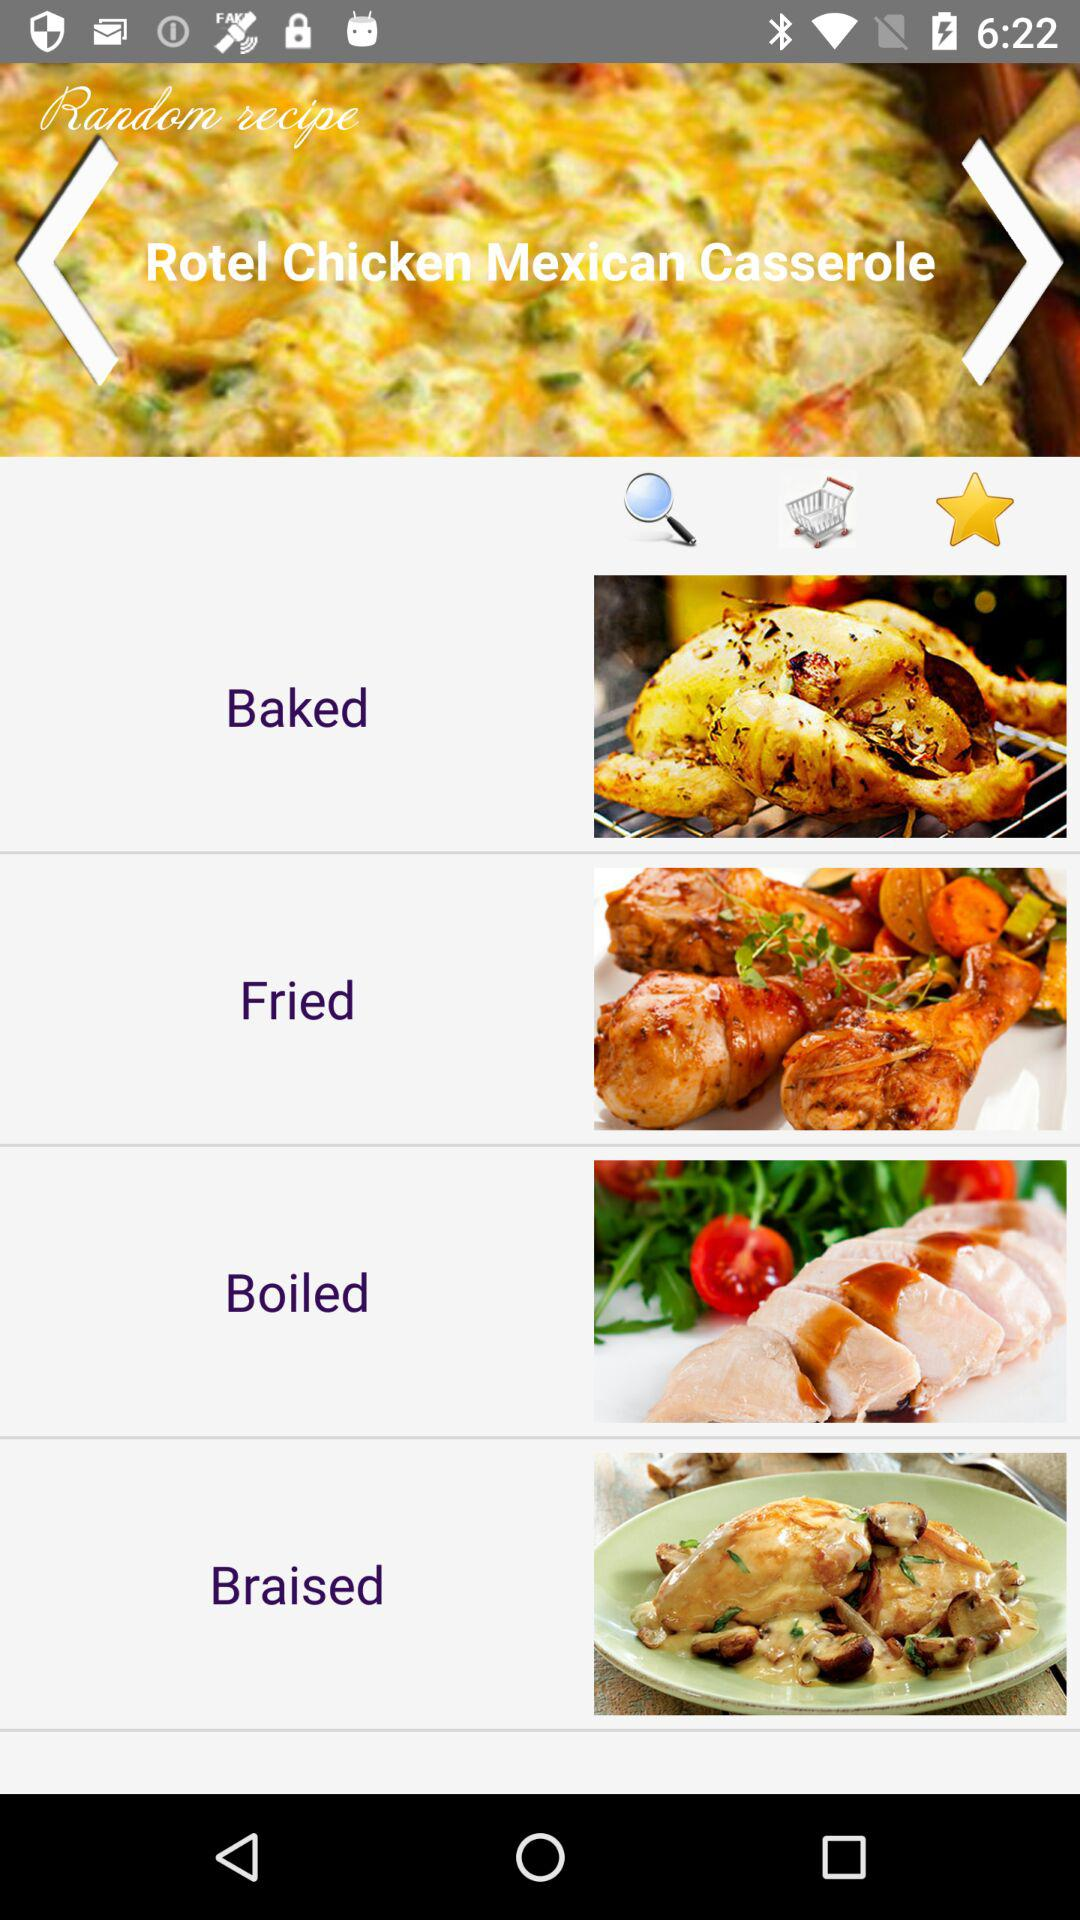How many cooking methods are there?
Answer the question using a single word or phrase. 4 